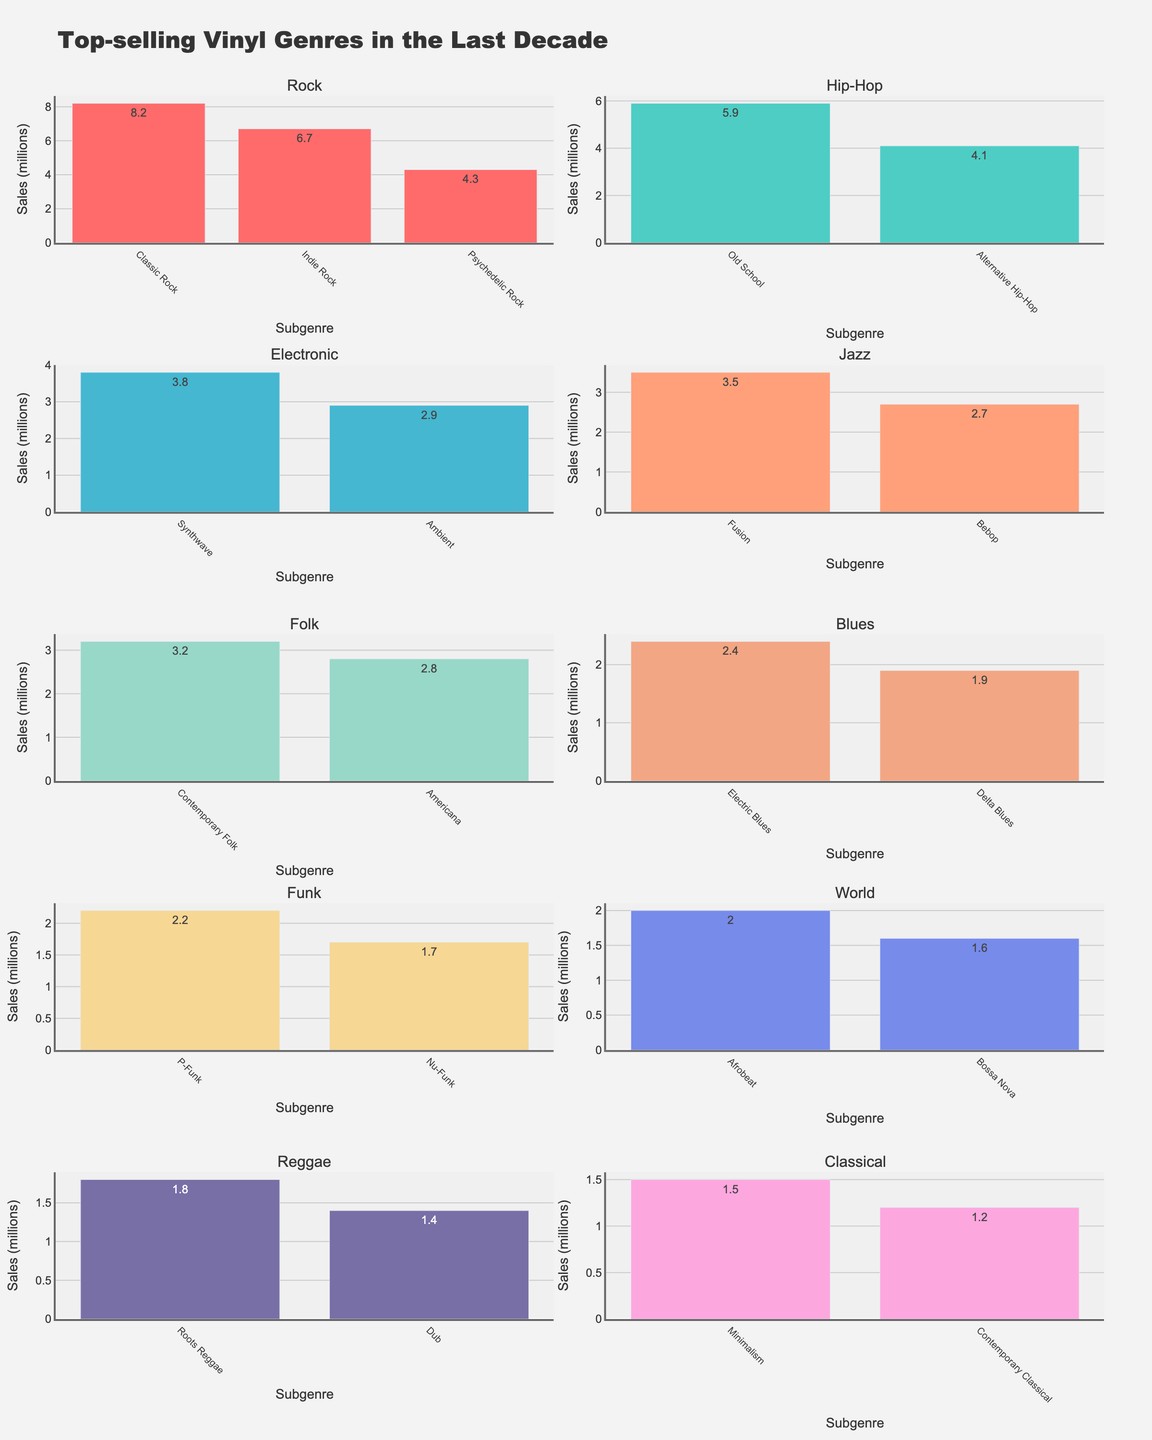What's the top-selling Rock subgenre? Look at the Rock genre section and identify the subgenre with the highest bar. "Classic Rock" has the highest bar in the Rock section.
Answer: Classic Rock Which genre has the subgenre with the lowest sales overall? Identify the subgenre with the shortest bar across all genres. "Contemporary Classical" in the Classical genre has the lowest bar.
Answer: Classical How do the sales of Electric Blues compare to Synthwave? Look at the bars for Electric Blues under the Blues genre and Synthwave under the Electronic genre. Electric Blues has a lower bar compared to Synthwave.
Answer: Lower What's the total sales for all subgenres under the Jazz genre? Sum the sales figures for Fusion and Bebop. Fusion (3.5) + Bebop (2.7) = 6.2 million.
Answer: 6.2 million Which subgenre has higher sales: Old School Hip-Hop or Indie Rock? Compare the heights of the bars for Old School under the Hip-Hop genre and Indie Rock under the Rock genre. Old School Hip-Hop (5.9) is higher than Indie Rock (6.7).
Answer: Indie Rock Are there more genres with at least one subgenre selling over 4 million than those under 2 million? Count the number of genres with subgenres surpassing 4 million (Rock: 3, Hip-Hop: 1). Then, count the genres with subgenres under 2 million (Blues: 2, Classical: 2, Funk: 1, World: 1, Reggae: 1). There are fewer genres with high-selling subgenres than those with lower-selling subgenres.
Answer: No What's the average sales figure for the Folk subgenres? Sum the sales figures for Contemporary Folk (3.2) and Americana (2.8) and then divide by 2. (3.2 + 2.8) / 2 = 3.
Answer: 3 million What subgenre has the highest sales in the World genre? In the World genre section, compare the bars for Afrobeat and Bossa Nova. Afrobeat has the highest bar.
Answer: Afrobeat Which genre's top-selling subgenre is closest in sales to Contemporary Folk? Compare the highest subgenre sales of each genre to 3.2 million of Contemporary Folk. Synthwave in Electronic (3.8) is the closest.
Answer: Electronic 